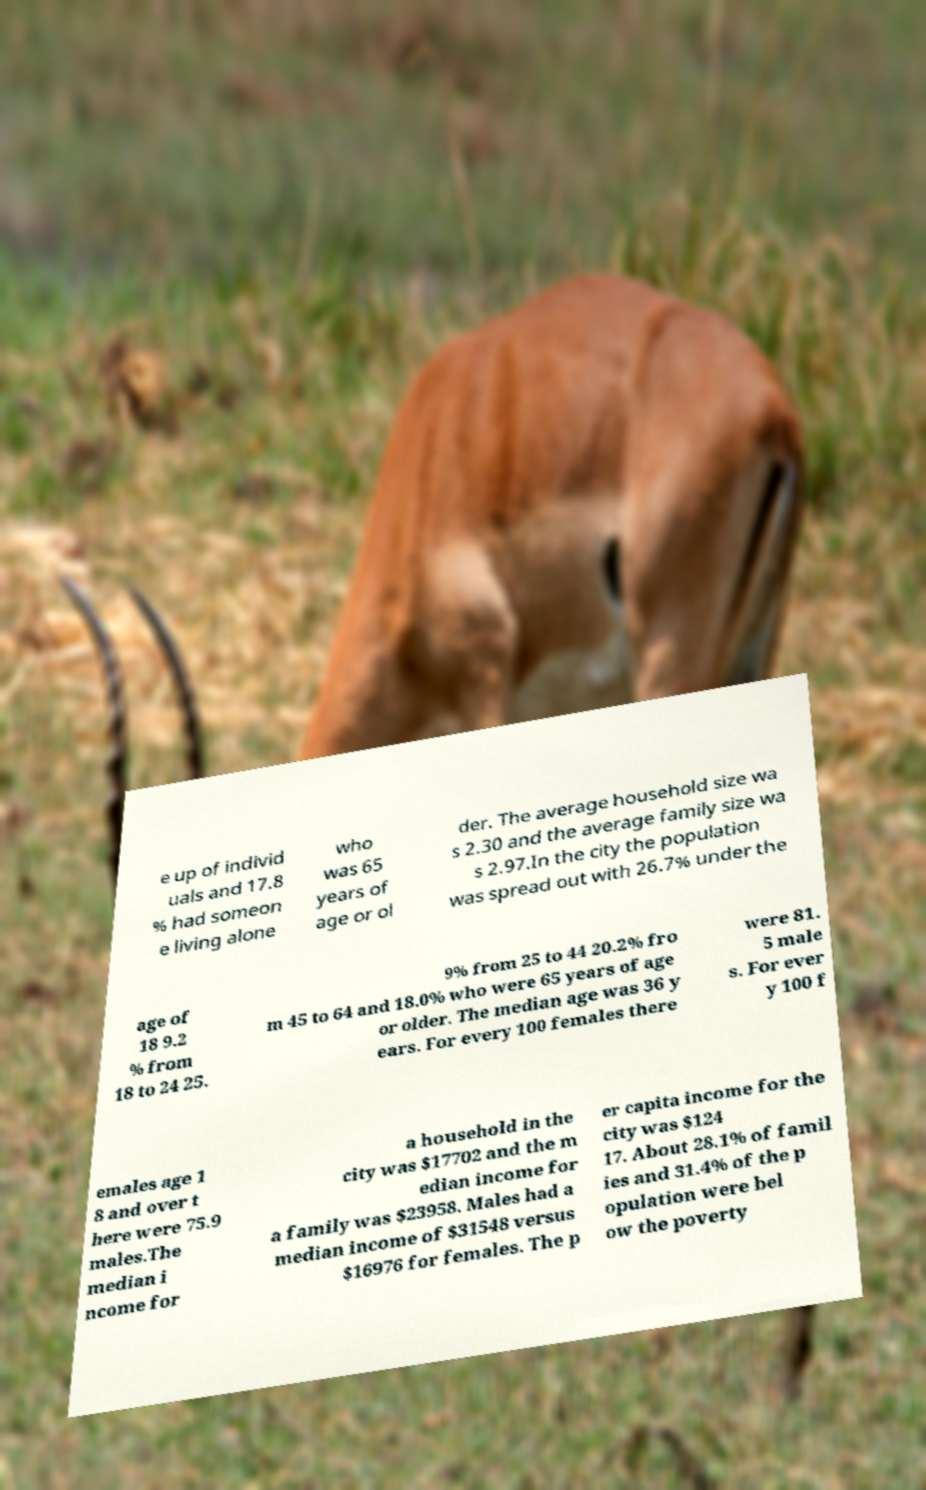There's text embedded in this image that I need extracted. Can you transcribe it verbatim? e up of individ uals and 17.8 % had someon e living alone who was 65 years of age or ol der. The average household size wa s 2.30 and the average family size wa s 2.97.In the city the population was spread out with 26.7% under the age of 18 9.2 % from 18 to 24 25. 9% from 25 to 44 20.2% fro m 45 to 64 and 18.0% who were 65 years of age or older. The median age was 36 y ears. For every 100 females there were 81. 5 male s. For ever y 100 f emales age 1 8 and over t here were 75.9 males.The median i ncome for a household in the city was $17702 and the m edian income for a family was $23958. Males had a median income of $31548 versus $16976 for females. The p er capita income for the city was $124 17. About 28.1% of famil ies and 31.4% of the p opulation were bel ow the poverty 